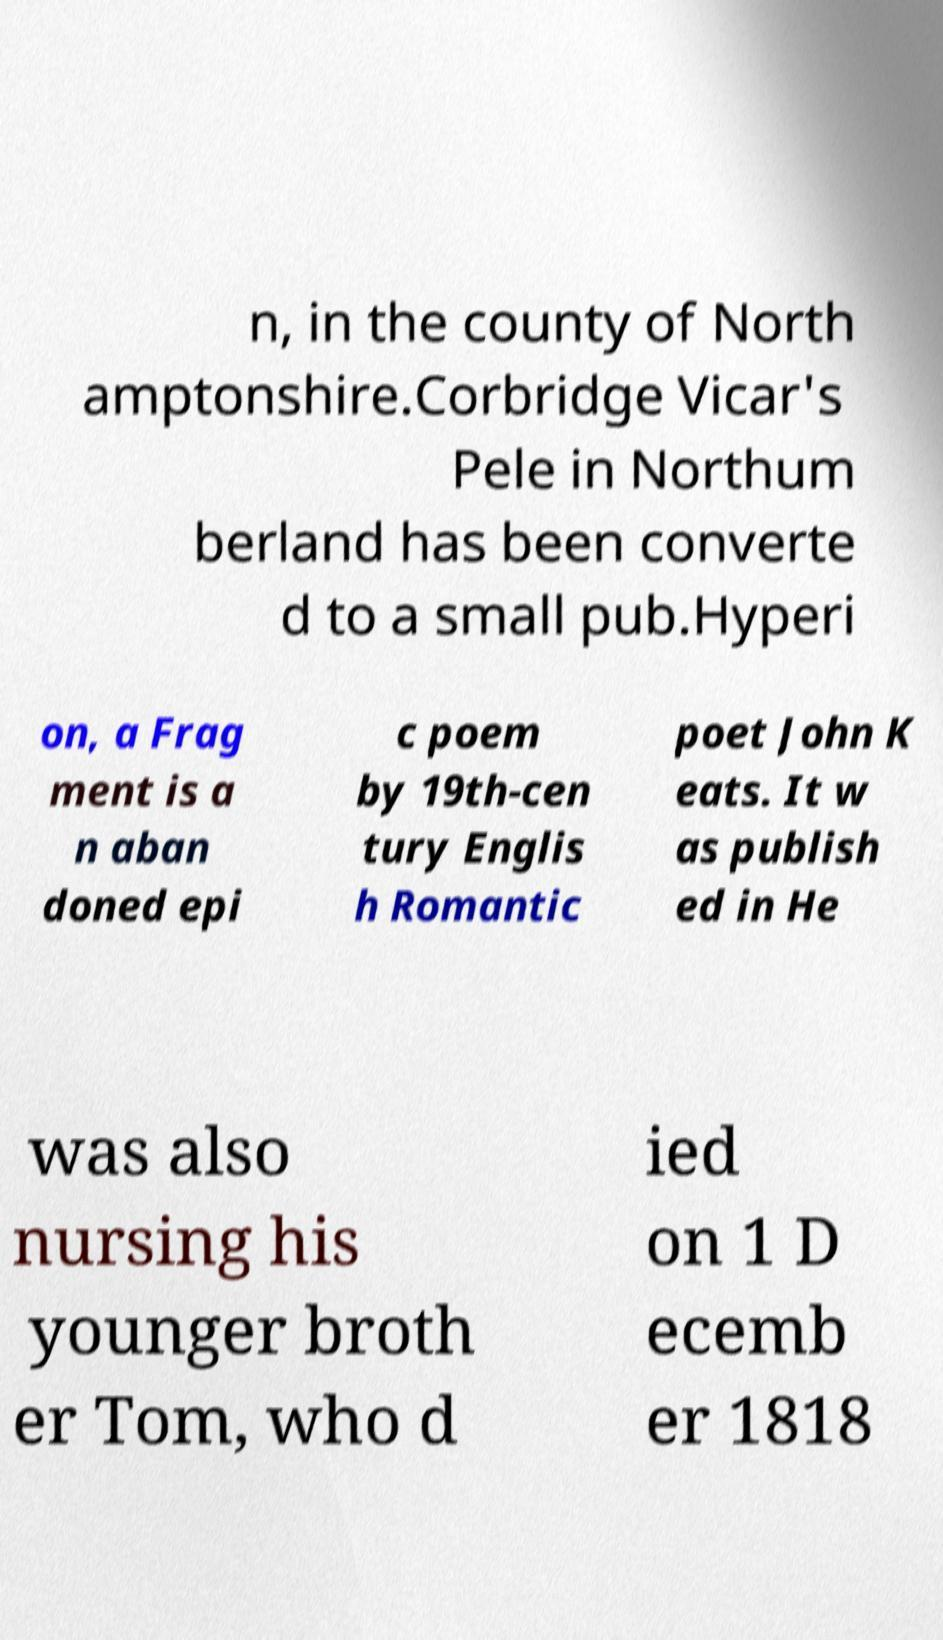Please read and relay the text visible in this image. What does it say? n, in the county of North amptonshire.Corbridge Vicar's Pele in Northum berland has been converte d to a small pub.Hyperi on, a Frag ment is a n aban doned epi c poem by 19th-cen tury Englis h Romantic poet John K eats. It w as publish ed in He was also nursing his younger broth er Tom, who d ied on 1 D ecemb er 1818 